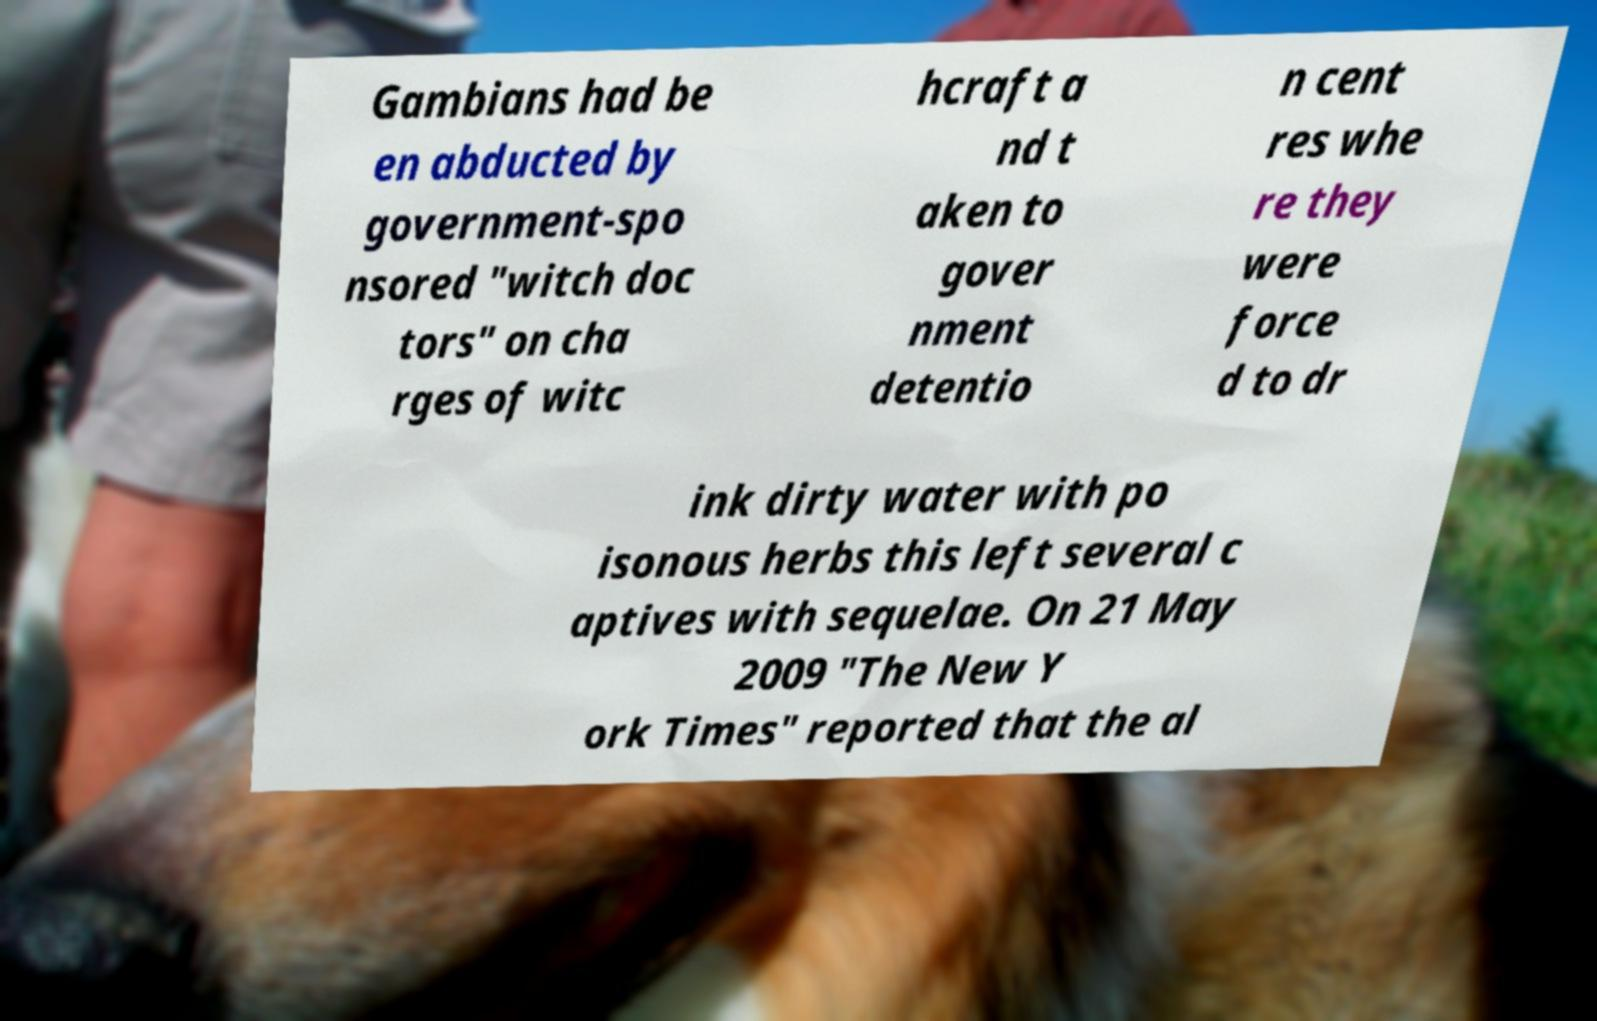Please read and relay the text visible in this image. What does it say? Gambians had be en abducted by government-spo nsored "witch doc tors" on cha rges of witc hcraft a nd t aken to gover nment detentio n cent res whe re they were force d to dr ink dirty water with po isonous herbs this left several c aptives with sequelae. On 21 May 2009 "The New Y ork Times" reported that the al 